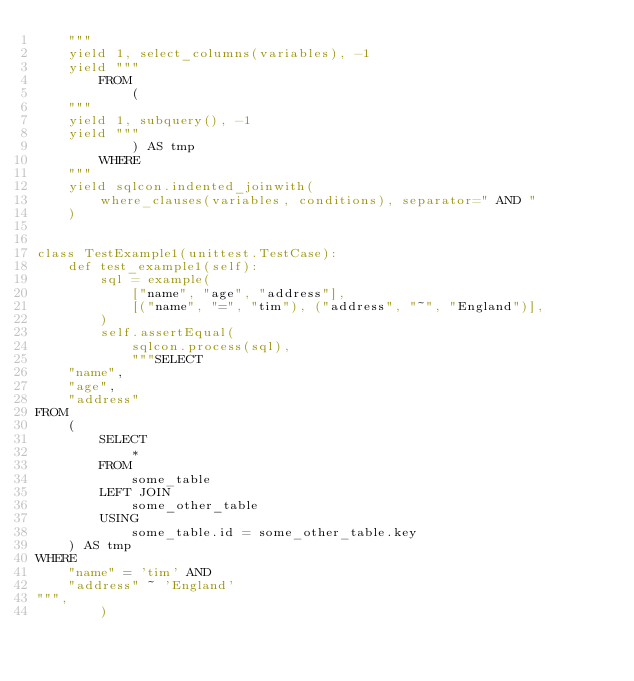<code> <loc_0><loc_0><loc_500><loc_500><_Python_>    """
    yield 1, select_columns(variables), -1
    yield """
        FROM
            (
    """
    yield 1, subquery(), -1
    yield """
            ) AS tmp
        WHERE
    """
    yield sqlcon.indented_joinwith(
        where_clauses(variables, conditions), separator=" AND "
    )


class TestExample1(unittest.TestCase):
    def test_example1(self):
        sql = example(
            ["name", "age", "address"],
            [("name", "=", "tim"), ("address", "~", "England")],
        )
        self.assertEqual(
            sqlcon.process(sql),
            """SELECT
    "name",
    "age",
    "address"
FROM
    (
        SELECT
            *
        FROM
            some_table
        LEFT JOIN
            some_other_table
        USING
            some_table.id = some_other_table.key
    ) AS tmp
WHERE
    "name" = 'tim' AND
    "address" ~ 'England'
""",
        )
</code> 